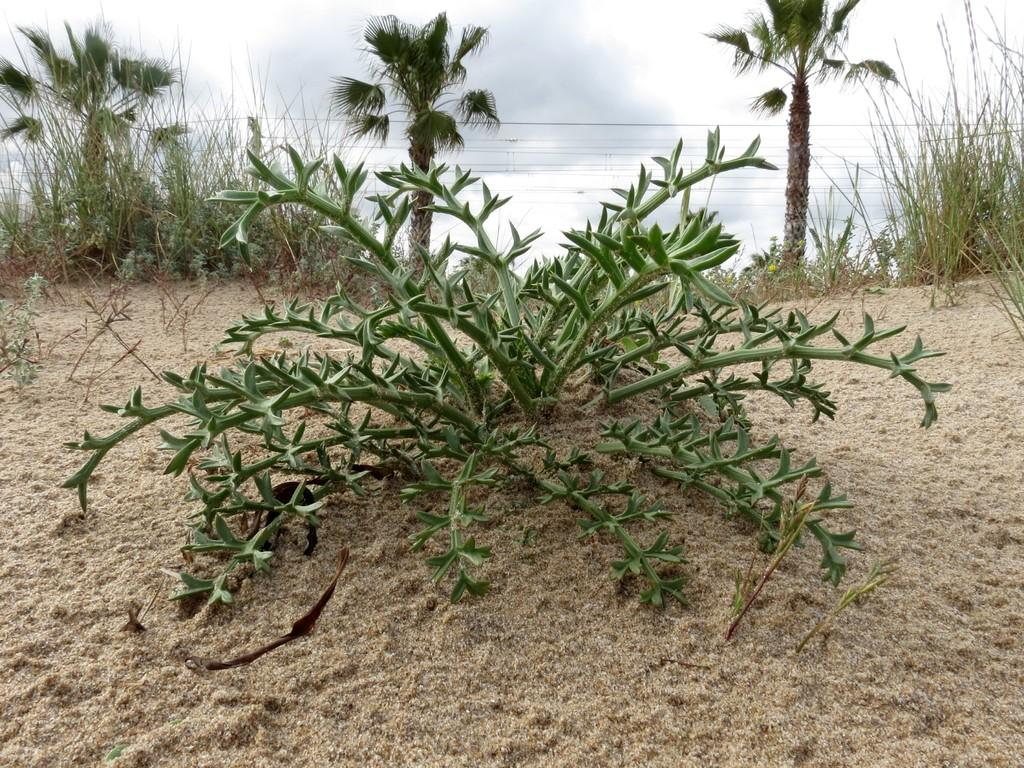What is the main subject in the center of the image? There is a plant in the center of the image. What type of surface is at the bottom of the image? There is sand at the bottom of the image. What can be seen in the background of the image? There are trees and the sky visible in the background of the image. What note is the plant playing in the image? There is no note being played in the image, as plants do not have the ability to play music. 